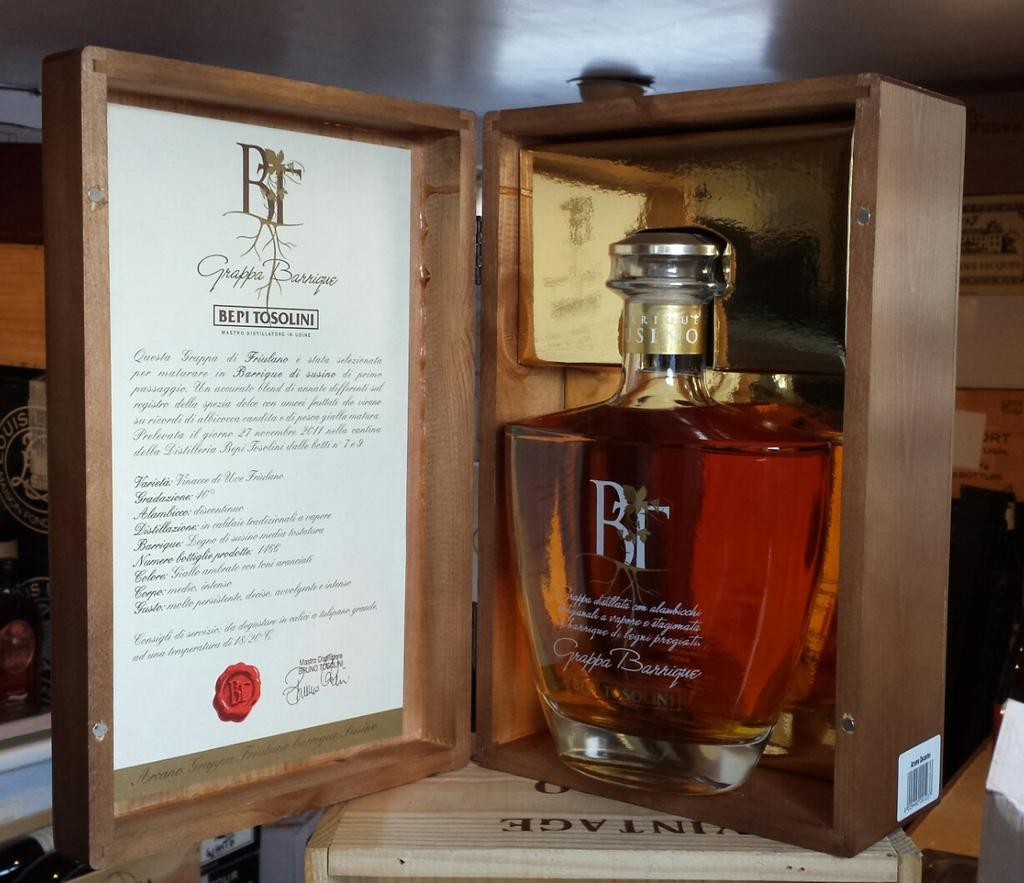Provide a one-sentence caption for the provided image. Bepi Tosolini branded alcohol with documentation in a wooden case. 